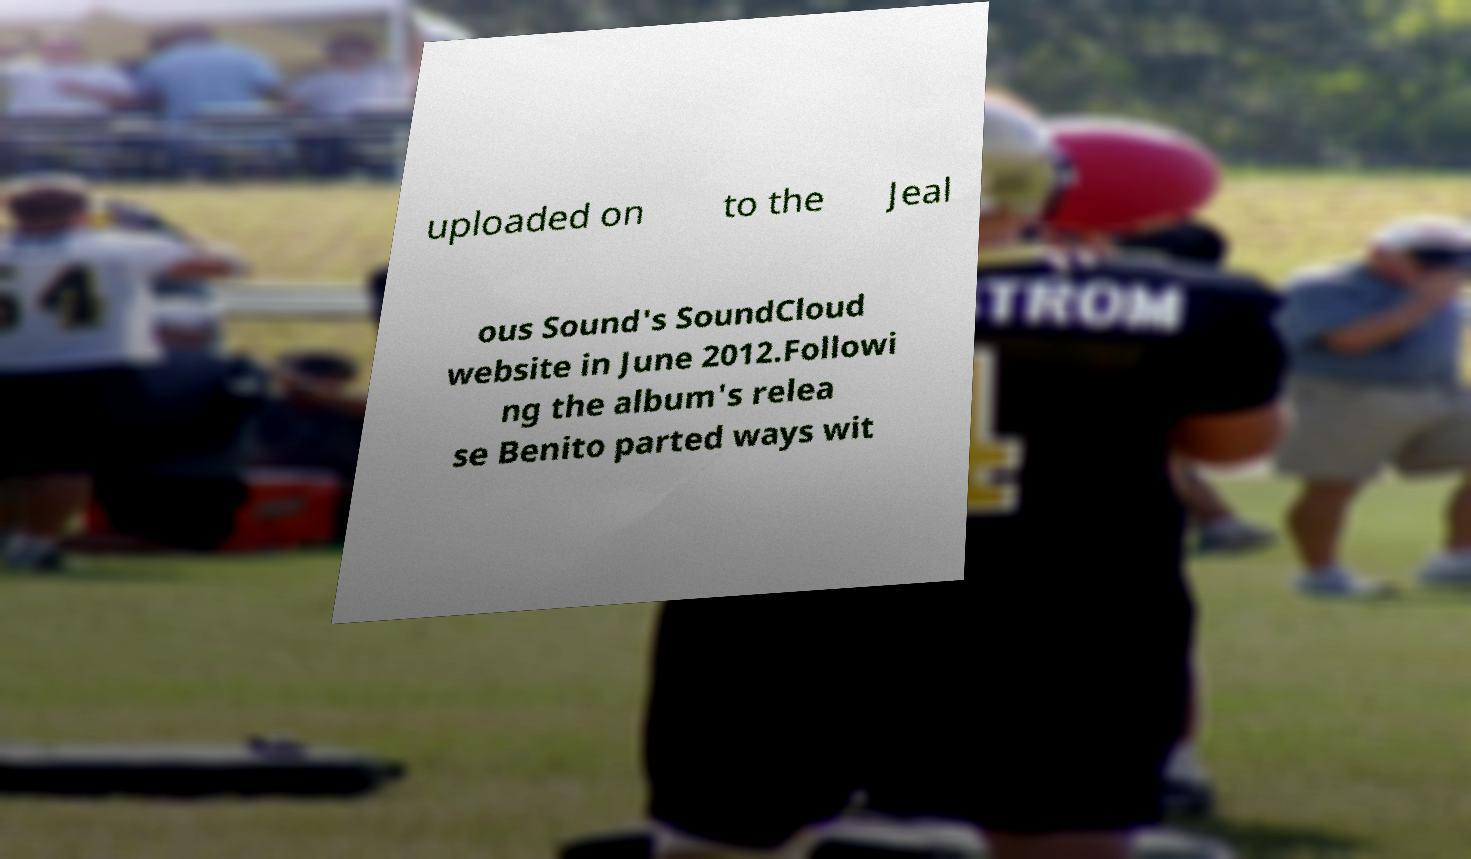Can you read and provide the text displayed in the image?This photo seems to have some interesting text. Can you extract and type it out for me? uploaded on to the Jeal ous Sound's SoundCloud website in June 2012.Followi ng the album's relea se Benito parted ways wit 